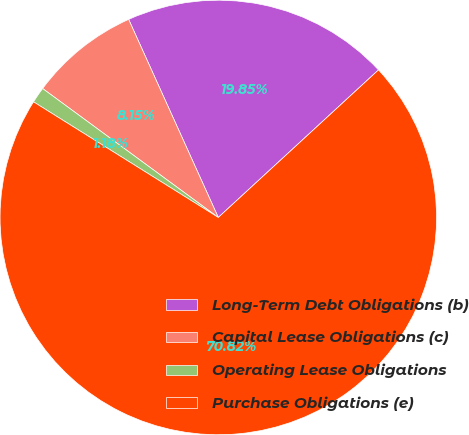Convert chart to OTSL. <chart><loc_0><loc_0><loc_500><loc_500><pie_chart><fcel>Long-Term Debt Obligations (b)<fcel>Capital Lease Obligations (c)<fcel>Operating Lease Obligations<fcel>Purchase Obligations (e)<nl><fcel>19.85%<fcel>8.15%<fcel>1.18%<fcel>70.81%<nl></chart> 